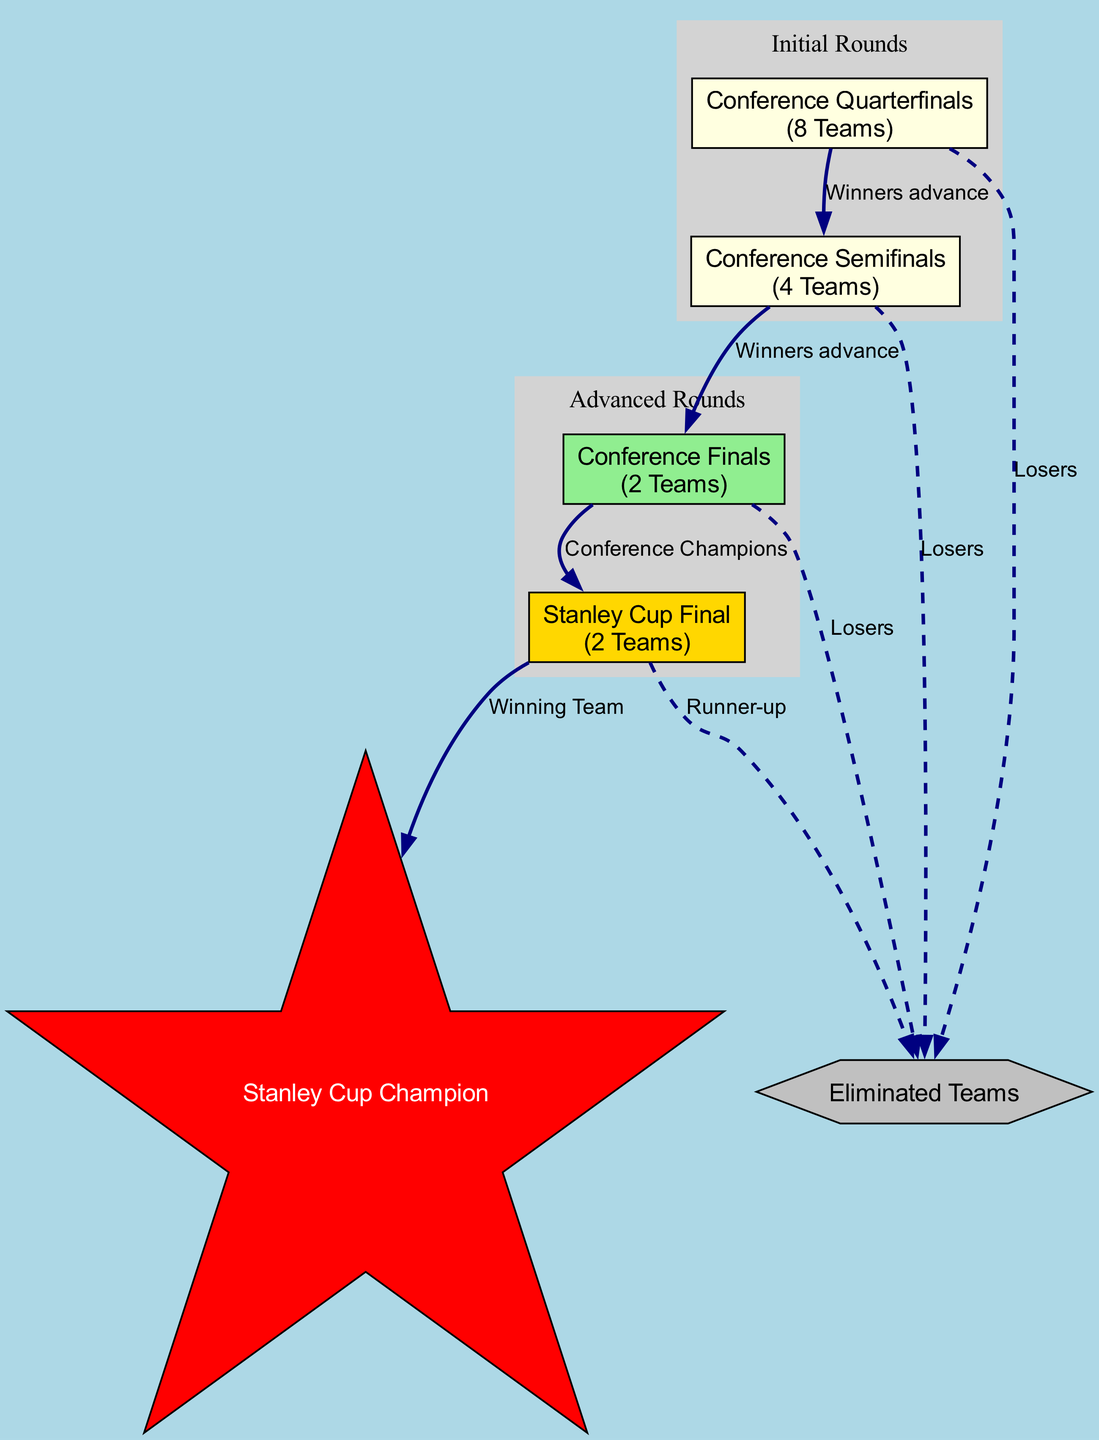What teams participate in the Conference Quarterfinals? The Conference Quarterfinals include all teams listed in the "Teams" section under "Initial Rounds," which are Team1, Team2, Team3, Team4, Team5, Team6, Team7, and Team8.
Answer: Team1, Team2, Team3, Team4, Team5, Team6, Team7, Team8 How many teams advance from the Conference Semifinals? Referring to the "Teams" section under "Conference Semifinals," it shows that 4 winners advance from this round, as indicated by "Winner_QF1" to "Winner_QF4."
Answer: 4 What happens to the losing teams in the Conference Quarterfinals? The diagram indicates that the losing teams in any round, including the Conference Quarterfinals, are connected to the "Eliminated Teams" node with a dashed edge, showing they are eliminated from the playoffs.
Answer: Eliminated Who competes in the Stanley Cup Final? According to the "Teams" section under "Stanley Cup Final," the participants are the Eastern Conference Champion and the Western Conference Champion.
Answer: Eastern Conference Champion, Western Conference Champion What is the flow from the Conference Finals to the Stanley Cup Champion? The diagram shows an edge labeled "Winners advance" from "CF" (Conference Finals) to the "SCF" (Stanley Cup Final), followed by an edge leading to the "Stanley Cup Champion" indicating that the winning team from the SCF becomes the champion.
Answer: Winning Team Which round has the fewest teams participating? By reviewing the teams listed in each round, the "Conference Finals" includes only 2 teams, which is fewer than any other round described in the diagram.
Answer: 2 What is the significance of the star-shaped node in the diagram? The star-shaped node labeled "Stanley Cup Champion" indicates the ultimate achievement for a team that wins the Stanley Cup Final, making it a significant milestone in the playoff structure.
Answer: Stanley Cup Champion What happens to the team that loses in the Stanley Cup Final? The diagram shows that the losing team in the Stanley Cup Final is connected to the "Eliminated Teams" node with a dashed edge, indicating they are the runner-up.
Answer: Runner-up 